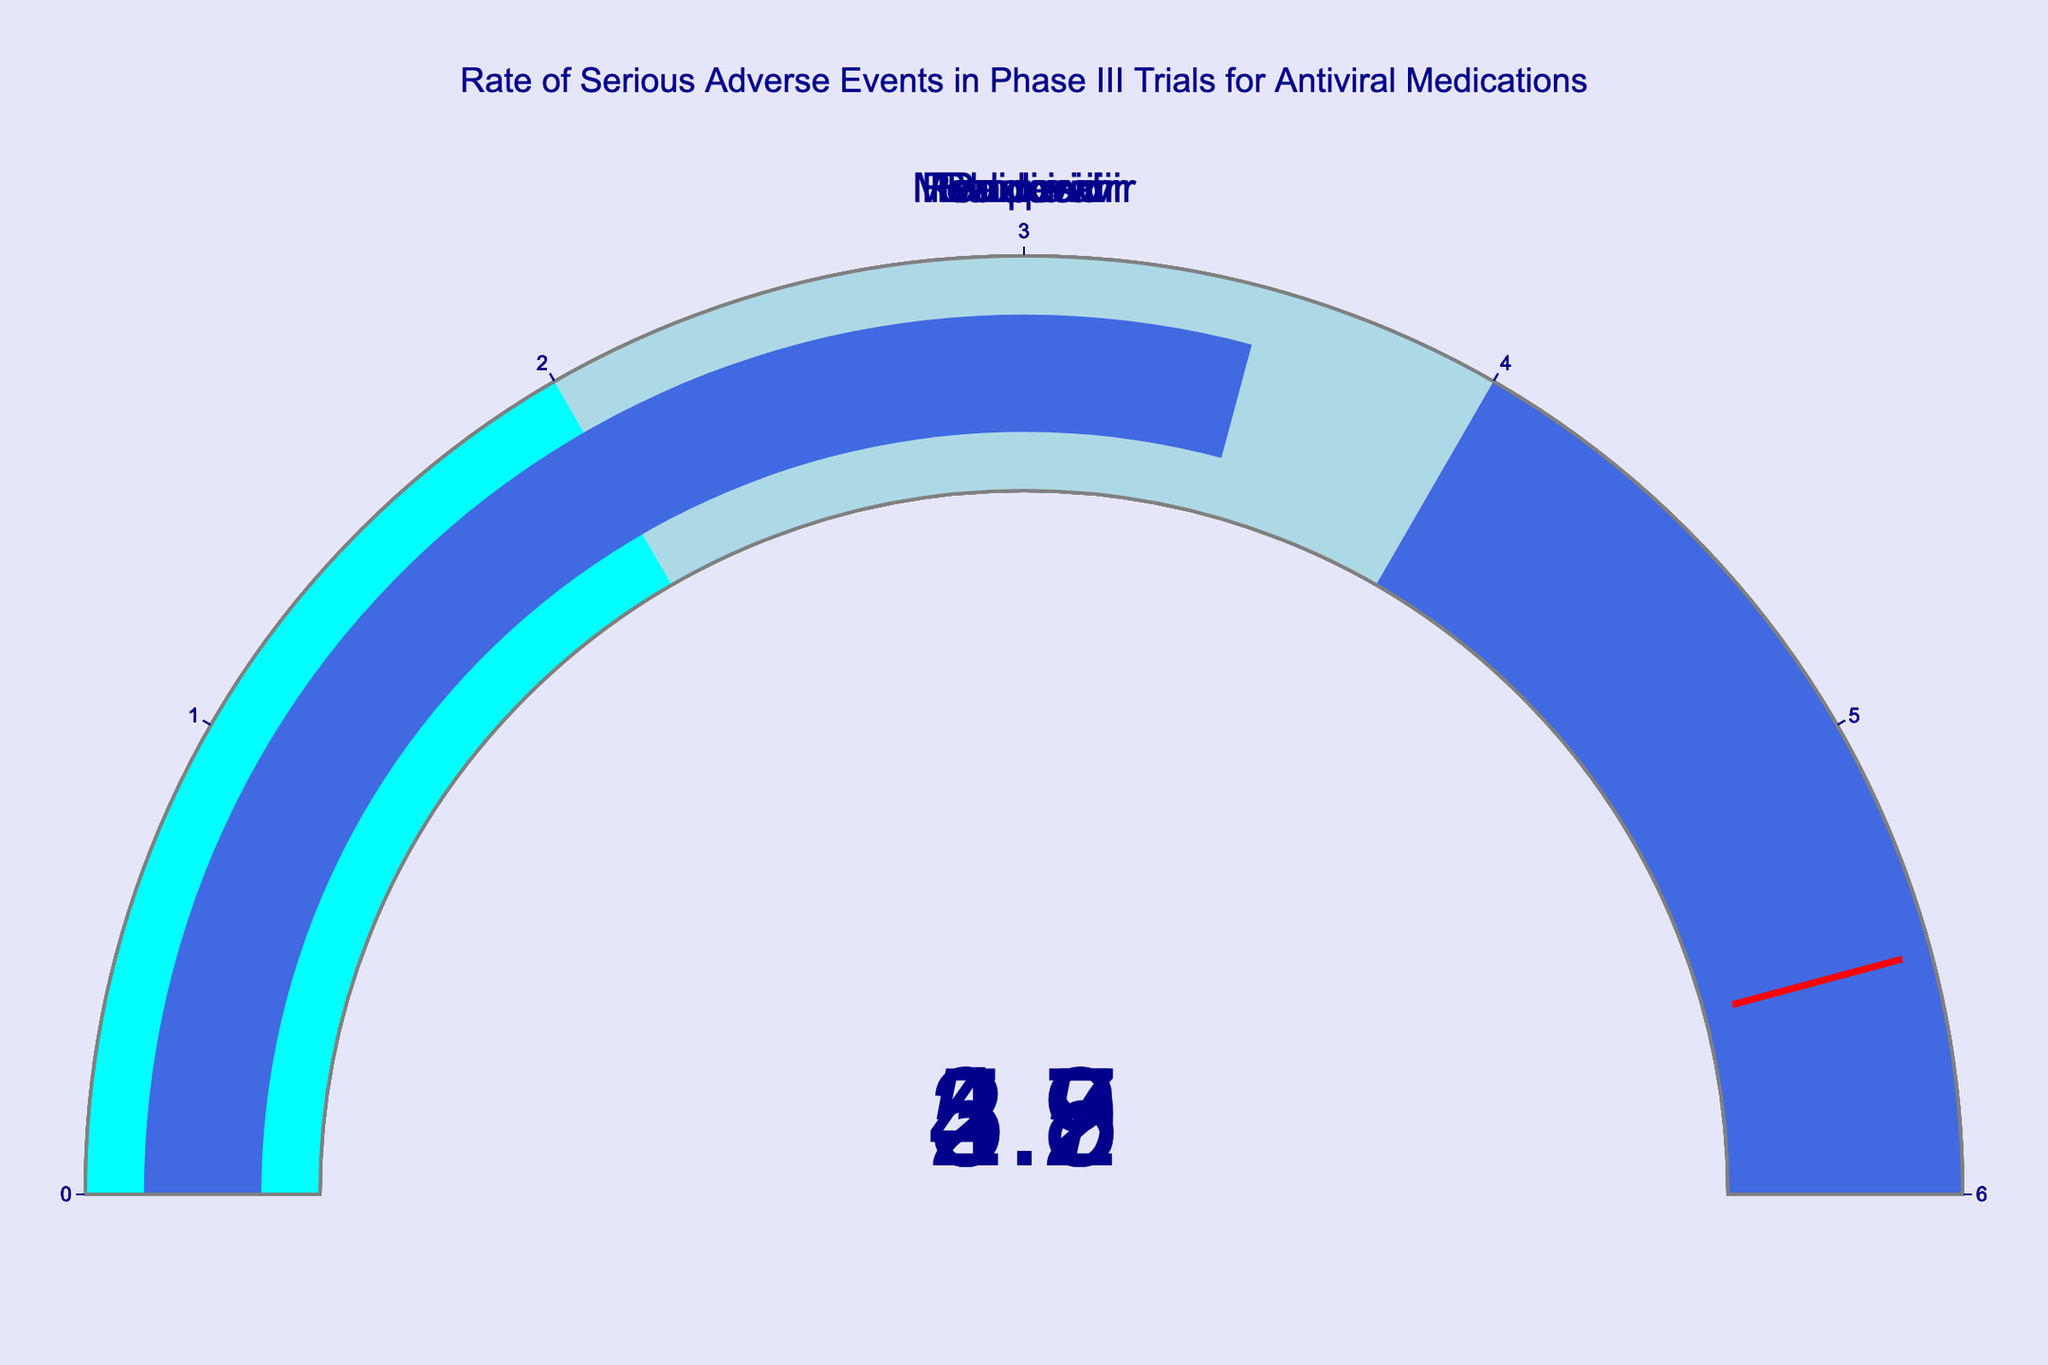What is the title of the figure? The title is located at the top of the figure, presenting what information the figure is displaying. By reading it, we can identify the overall topic of the data visualized.
Answer: "Rate of Serious Adverse Events in Phase III Trials for Antiviral Medications" Which drug has the highest rate of serious adverse events? By examining the gauge charts, look for the one with the highest value indicated on the gauge. This is the maximum among all the displayed drugs.
Answer: Remdesivir Compare the adverse event rates of Paxlovid and Molnupiravir. Which one is higher? Check the values indicated on the gauge charts for both Paxlovid and Molnupiravir. Compare these two values to determine which one is higher.
Answer: Molnupiravir What is the range of the gauge charts? The range of each gauge can be determined by inspecting the scale or axis of any of the gauges since they are uniformly set.
Answer: 0 to 6 How many antiviral drugs have an adverse event rate lower than 4? Check each gauge and count the number of drugs that have a value indicated below 4 on the gauge.
Answer: 3 Calculate the average adverse event rate of all the drugs. Sum the adverse event rates of all the drugs and divide this sum by the number of drugs. The rates are 5.2, 3.8, 4.7, 2.9, and 3.5. The sum is 20.1 and the number of drugs is 5. Average = 20.1 / 5 = 4.02.
Answer: 4.02 Which drug has the lowest rate of serious adverse events? By examining the gauge charts, look for the one with the lowest value indicated on the gauge. This is the minimum among all the displayed drugs.
Answer: Paxlovid What color represents the highest range (between 4 and 6) on the gauge charts? Inspect the color coding of the gauge charts. The ranges are color-coded, so identify the color corresponding to the 4 to 6 range.
Answer: Royal blue How many different color steps are used in the gauge charts? Inspect the steps within the gauge and count the distinct color divisions representing different ranges.
Answer: 3 Based on the thresholds, how many drugs are above the threshold value of 5.5? Check each gauge to see if the adverse event rate surpasses the threshold line indicating the value of 5.5.
Answer: None 